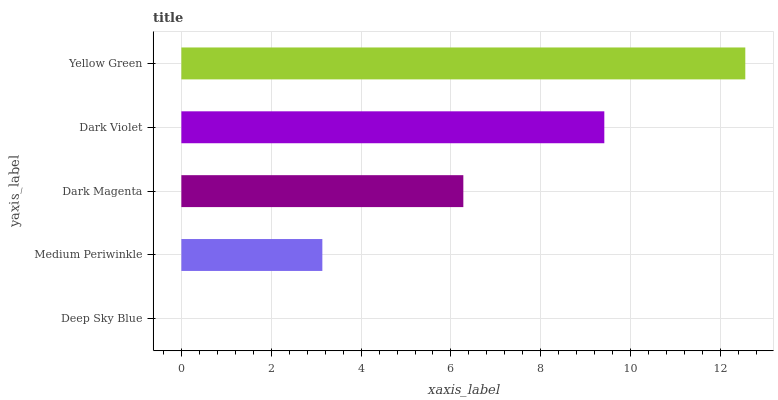Is Deep Sky Blue the minimum?
Answer yes or no. Yes. Is Yellow Green the maximum?
Answer yes or no. Yes. Is Medium Periwinkle the minimum?
Answer yes or no. No. Is Medium Periwinkle the maximum?
Answer yes or no. No. Is Medium Periwinkle greater than Deep Sky Blue?
Answer yes or no. Yes. Is Deep Sky Blue less than Medium Periwinkle?
Answer yes or no. Yes. Is Deep Sky Blue greater than Medium Periwinkle?
Answer yes or no. No. Is Medium Periwinkle less than Deep Sky Blue?
Answer yes or no. No. Is Dark Magenta the high median?
Answer yes or no. Yes. Is Dark Magenta the low median?
Answer yes or no. Yes. Is Medium Periwinkle the high median?
Answer yes or no. No. Is Yellow Green the low median?
Answer yes or no. No. 